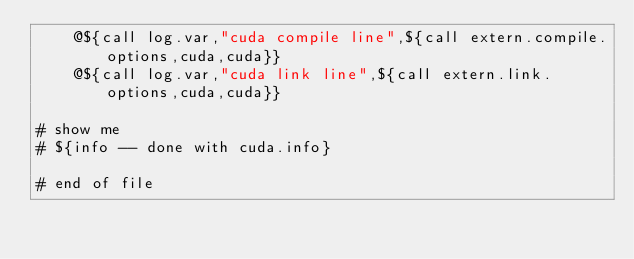Convert code to text. <code><loc_0><loc_0><loc_500><loc_500><_ObjectiveC_>	@${call log.var,"cuda compile line",${call extern.compile.options,cuda,cuda}}
	@${call log.var,"cuda link line",${call extern.link.options,cuda,cuda}}

# show me
# ${info -- done with cuda.info}

# end of file
</code> 